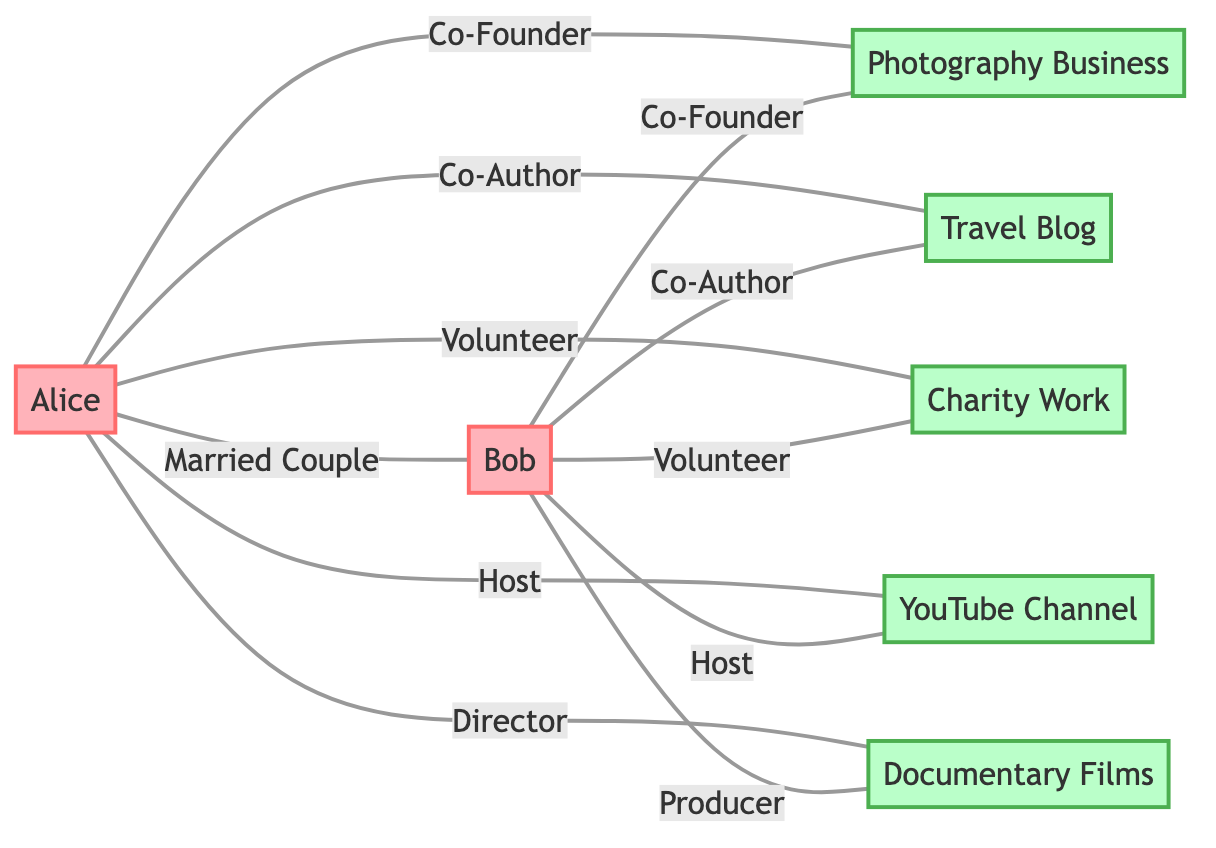What are the main projects the couple is involved in? The edges leading to the project nodes are "Photography Business," "Travel Blog," "Charity Work," "YouTube Channel," and "Documentary Films." Thus, the main projects are the listed five.
Answer: Photography Business, Travel Blog, Charity Work, YouTube Channel, Documentary Films How many total nodes are present in the diagram? Counting the nodes for the couple and their collaborative projects, there are 7 nodes in total: Alice, Bob, and the 5 collaborative projects.
Answer: 7 What is the relationship type between Alice and Bob? The edge connecting Alice and Bob is labeled "Married Couple," which specifies their relationship type.
Answer: Married Couple How many projects do both Alice and Bob co-author? Both are connected by edges labeled "Co-Author" to the "Travel Blog," indicating they work together on that project. Thus, there is 1 project they co-author.
Answer: 1 Which role does Alice have in the "Documentary Films"? Looking at the edge connecting Alice to the "Documentary Films," it is labeled "Director," which indicates her specific role.
Answer: Director How many collaborative projects involve both Alice and Bob? All edges from Alice to projects also have a corresponding edge from Bob to the same projects, leading to a total of 5 collaborative projects: Photography Business, Travel Blog, Charity Work, YouTube Channel, and Documentary Films.
Answer: 5 Which role does Bob play in the YouTube Channel? The edge from Bob to "YouTube Channel" is labeled "Host," which clearly indicates his role in this project.
Answer: Host What is the common activity between Alice and Bob and the Charity Work? Both Alice and Bob are connected to "Charity Work" with edges labeled "Volunteer," meaning they engage in volunteering together for this project.
Answer: Volunteer What is the total number of edges in the diagram? Counting all the connections, there are 10 edges shown between the couple and their various projects.
Answer: 10 